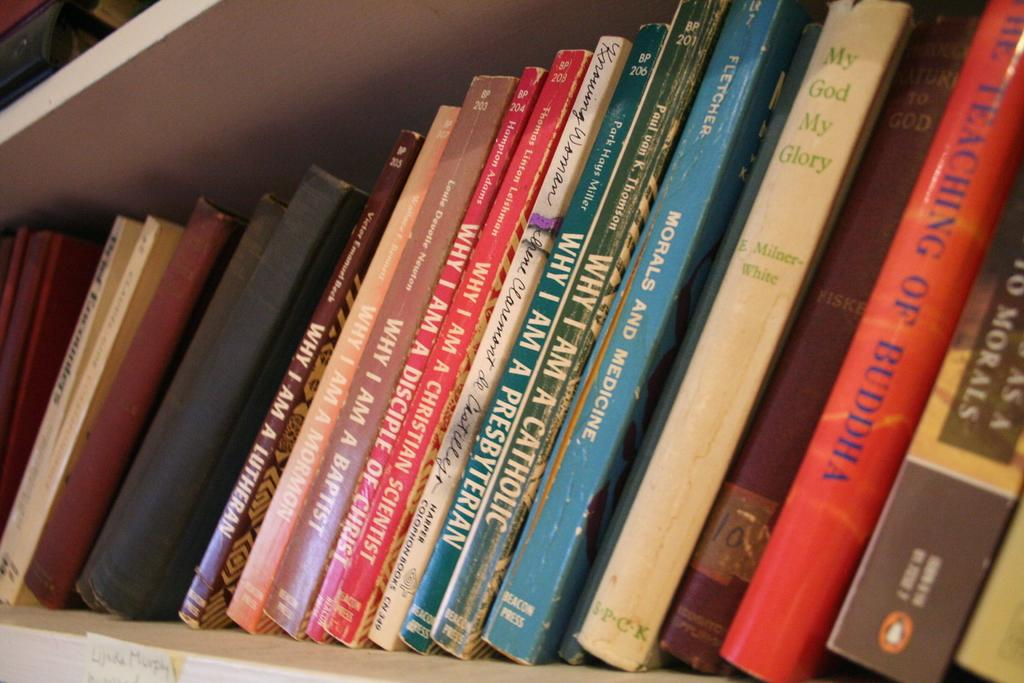<image>
Summarize the visual content of the image. A shelf filled with books includes one titled Why I am a Catholic. 